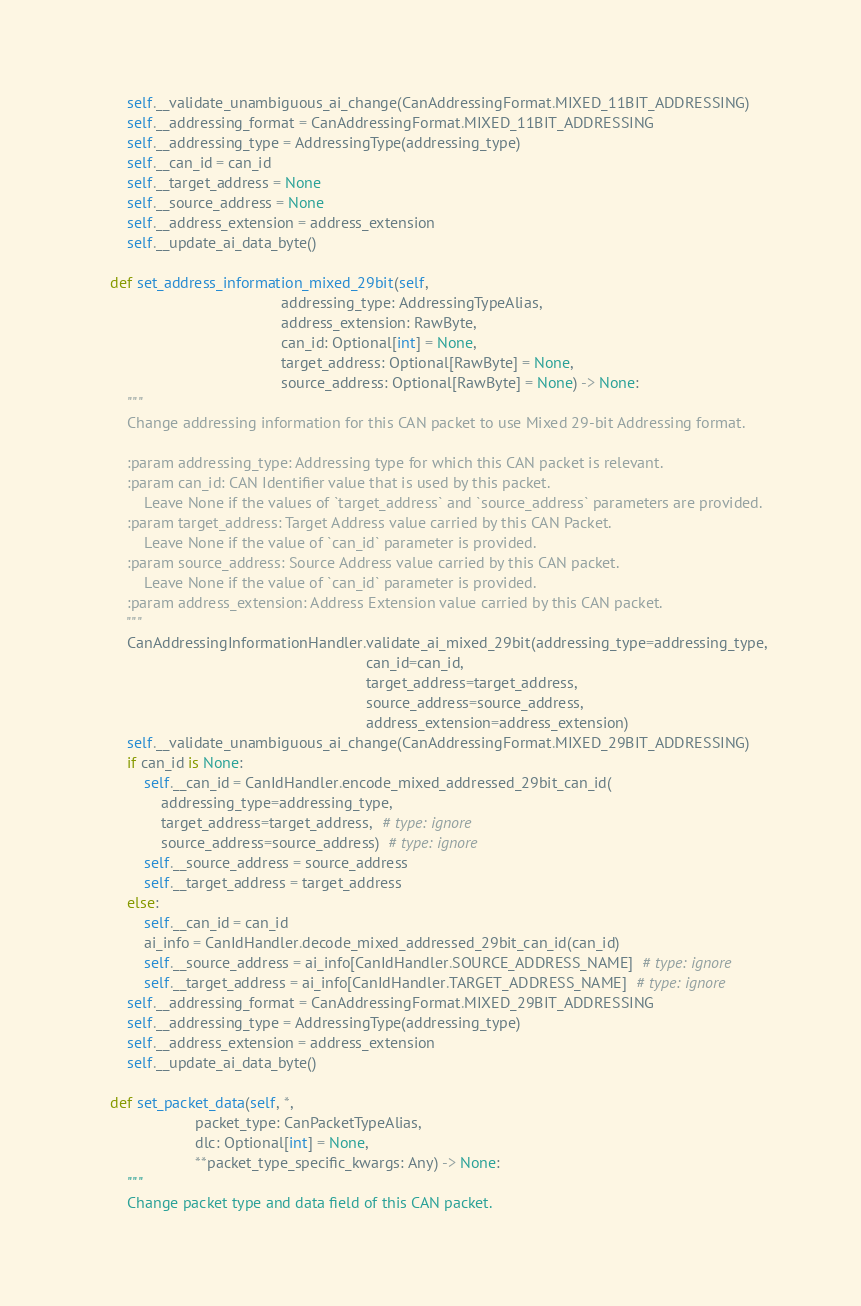<code> <loc_0><loc_0><loc_500><loc_500><_Python_>        self.__validate_unambiguous_ai_change(CanAddressingFormat.MIXED_11BIT_ADDRESSING)
        self.__addressing_format = CanAddressingFormat.MIXED_11BIT_ADDRESSING
        self.__addressing_type = AddressingType(addressing_type)
        self.__can_id = can_id
        self.__target_address = None
        self.__source_address = None
        self.__address_extension = address_extension
        self.__update_ai_data_byte()

    def set_address_information_mixed_29bit(self,
                                            addressing_type: AddressingTypeAlias,
                                            address_extension: RawByte,
                                            can_id: Optional[int] = None,
                                            target_address: Optional[RawByte] = None,
                                            source_address: Optional[RawByte] = None) -> None:
        """
        Change addressing information for this CAN packet to use Mixed 29-bit Addressing format.

        :param addressing_type: Addressing type for which this CAN packet is relevant.
        :param can_id: CAN Identifier value that is used by this packet.
            Leave None if the values of `target_address` and `source_address` parameters are provided.
        :param target_address: Target Address value carried by this CAN Packet.
            Leave None if the value of `can_id` parameter is provided.
        :param source_address: Source Address value carried by this CAN packet.
            Leave None if the value of `can_id` parameter is provided.
        :param address_extension: Address Extension value carried by this CAN packet.
        """
        CanAddressingInformationHandler.validate_ai_mixed_29bit(addressing_type=addressing_type,
                                                                can_id=can_id,
                                                                target_address=target_address,
                                                                source_address=source_address,
                                                                address_extension=address_extension)
        self.__validate_unambiguous_ai_change(CanAddressingFormat.MIXED_29BIT_ADDRESSING)
        if can_id is None:
            self.__can_id = CanIdHandler.encode_mixed_addressed_29bit_can_id(
                addressing_type=addressing_type,
                target_address=target_address,  # type: ignore
                source_address=source_address)  # type: ignore
            self.__source_address = source_address
            self.__target_address = target_address
        else:
            self.__can_id = can_id
            ai_info = CanIdHandler.decode_mixed_addressed_29bit_can_id(can_id)
            self.__source_address = ai_info[CanIdHandler.SOURCE_ADDRESS_NAME]  # type: ignore
            self.__target_address = ai_info[CanIdHandler.TARGET_ADDRESS_NAME]  # type: ignore
        self.__addressing_format = CanAddressingFormat.MIXED_29BIT_ADDRESSING
        self.__addressing_type = AddressingType(addressing_type)
        self.__address_extension = address_extension
        self.__update_ai_data_byte()

    def set_packet_data(self, *,
                        packet_type: CanPacketTypeAlias,
                        dlc: Optional[int] = None,
                        **packet_type_specific_kwargs: Any) -> None:
        """
        Change packet type and data field of this CAN packet.
</code> 